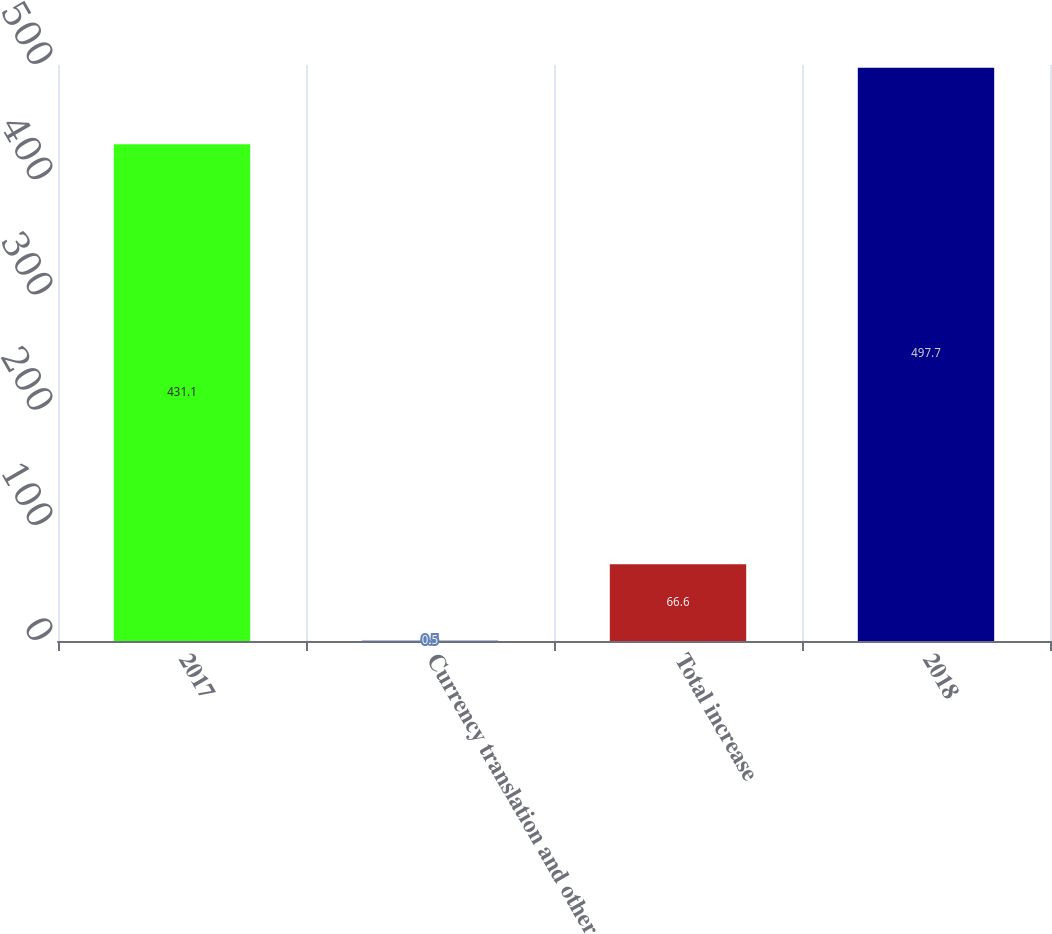Convert chart. <chart><loc_0><loc_0><loc_500><loc_500><bar_chart><fcel>2017<fcel>Currency translation and other<fcel>Total increase<fcel>2018<nl><fcel>431.1<fcel>0.5<fcel>66.6<fcel>497.7<nl></chart> 